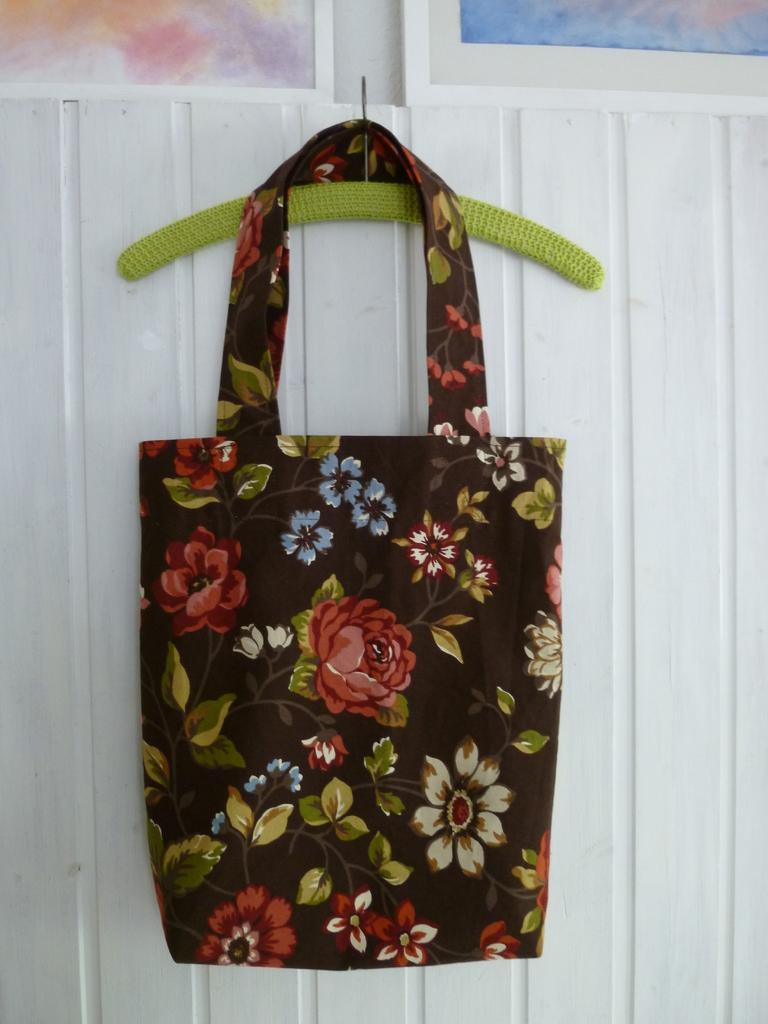What is hanging on the wall in the image? There is a bag hanging on a pin on the wall in the image. What color is the bag? The bag is black. What is the color of the wall? The wall is white. What design can be seen on the bag? Flowers are printed on the bag. What type of clover can be seen growing on the wall in the image? There is no clover present in the image; the wall is white and has a black bag hanging on it. Can you describe the air quality in the image? The image does not provide any information about the air quality; it only shows a bag hanging on a white wall. 